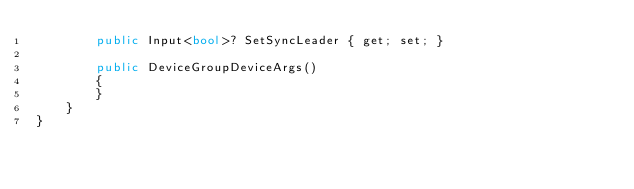<code> <loc_0><loc_0><loc_500><loc_500><_C#_>        public Input<bool>? SetSyncLeader { get; set; }

        public DeviceGroupDeviceArgs()
        {
        }
    }
}
</code> 